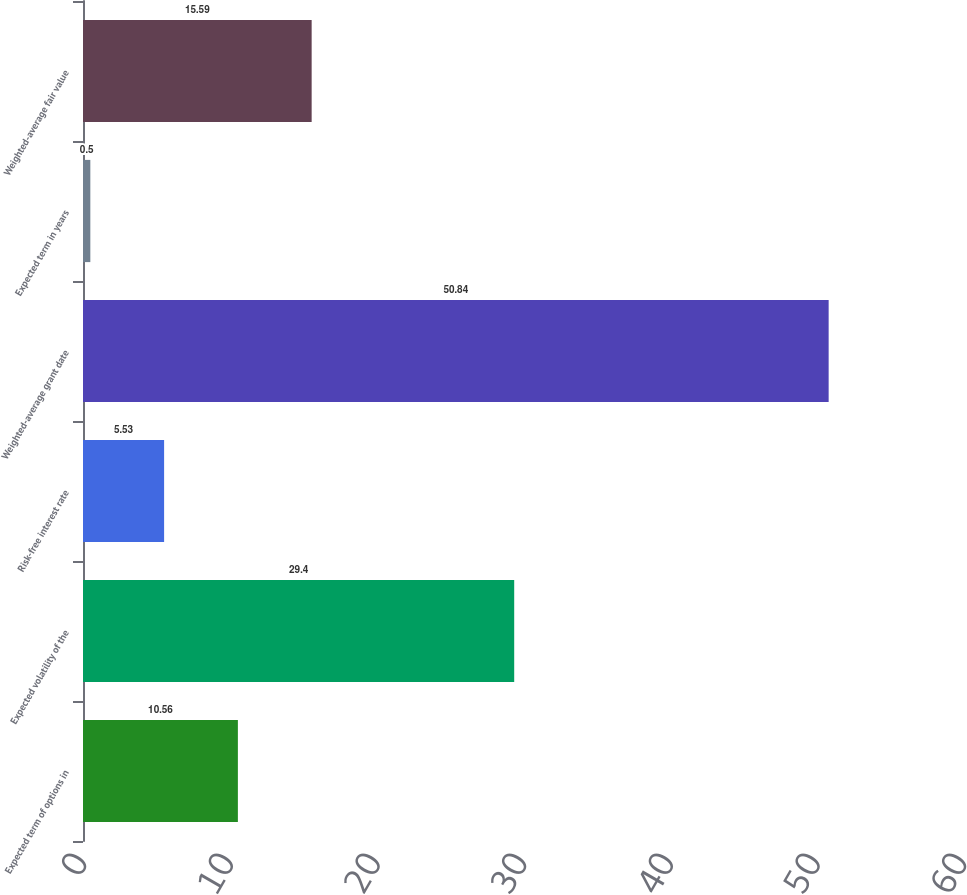Convert chart to OTSL. <chart><loc_0><loc_0><loc_500><loc_500><bar_chart><fcel>Expected term of options in<fcel>Expected volatility of the<fcel>Risk-free interest rate<fcel>Weighted-average grant date<fcel>Expected term in years<fcel>Weighted-average fair value<nl><fcel>10.56<fcel>29.4<fcel>5.53<fcel>50.84<fcel>0.5<fcel>15.59<nl></chart> 